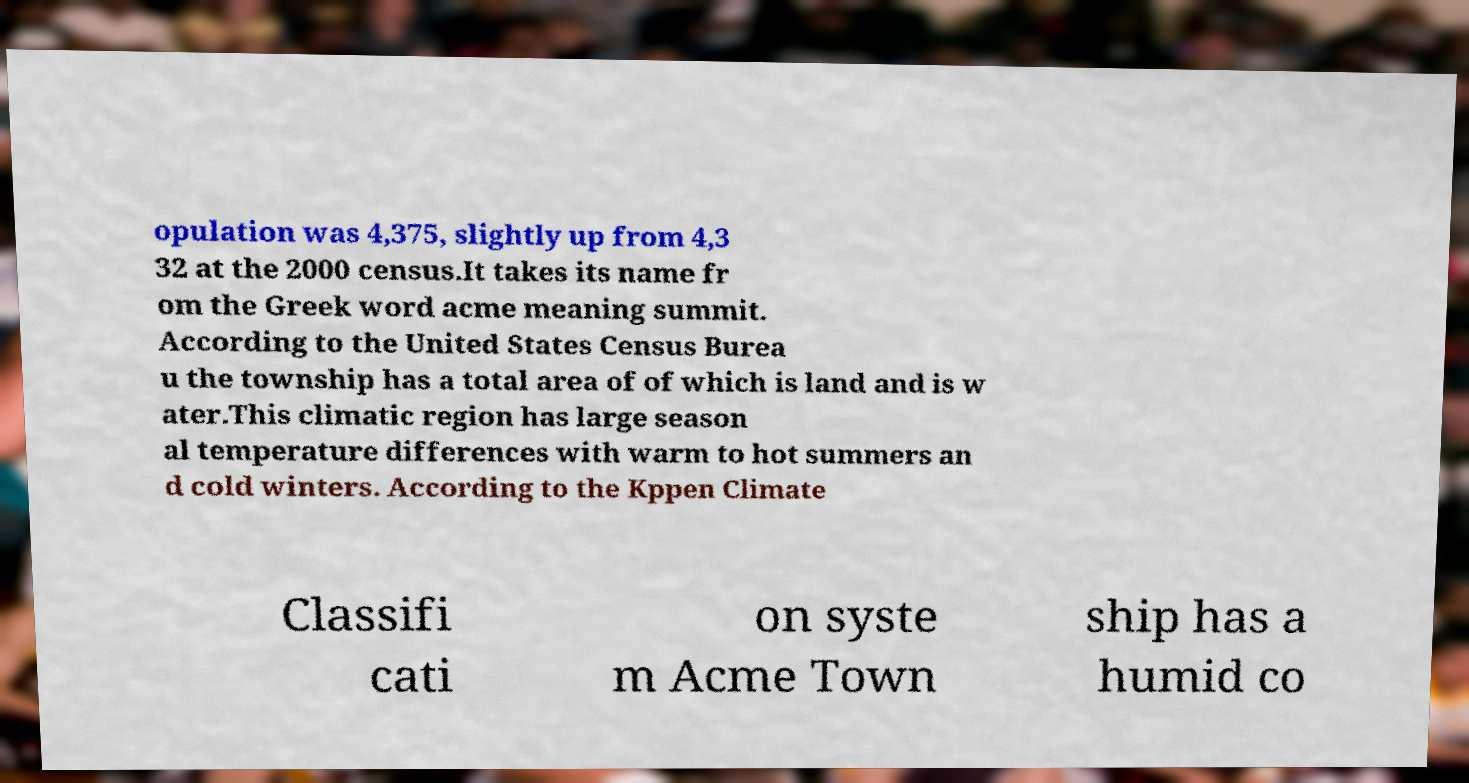Could you assist in decoding the text presented in this image and type it out clearly? opulation was 4,375, slightly up from 4,3 32 at the 2000 census.It takes its name fr om the Greek word acme meaning summit. According to the United States Census Burea u the township has a total area of of which is land and is w ater.This climatic region has large season al temperature differences with warm to hot summers an d cold winters. According to the Kppen Climate Classifi cati on syste m Acme Town ship has a humid co 